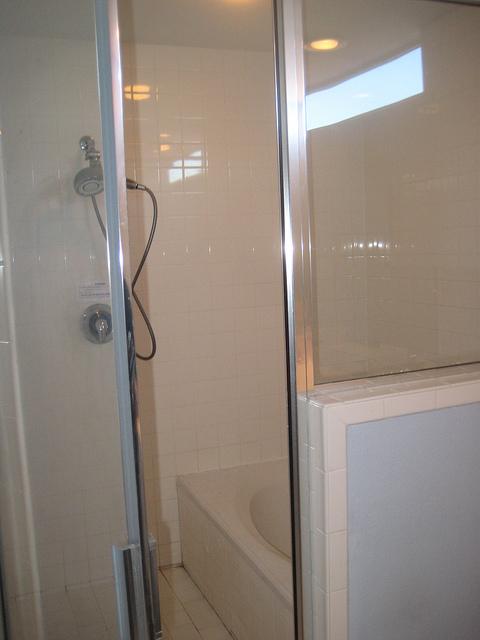Is it a electronic light  lighting this room?
Write a very short answer. Yes. Where does this door lead to?
Give a very brief answer. Shower. Would you need a towel if you used this facility?
Short answer required. Yes. Is the shower being used?
Give a very brief answer. No. 